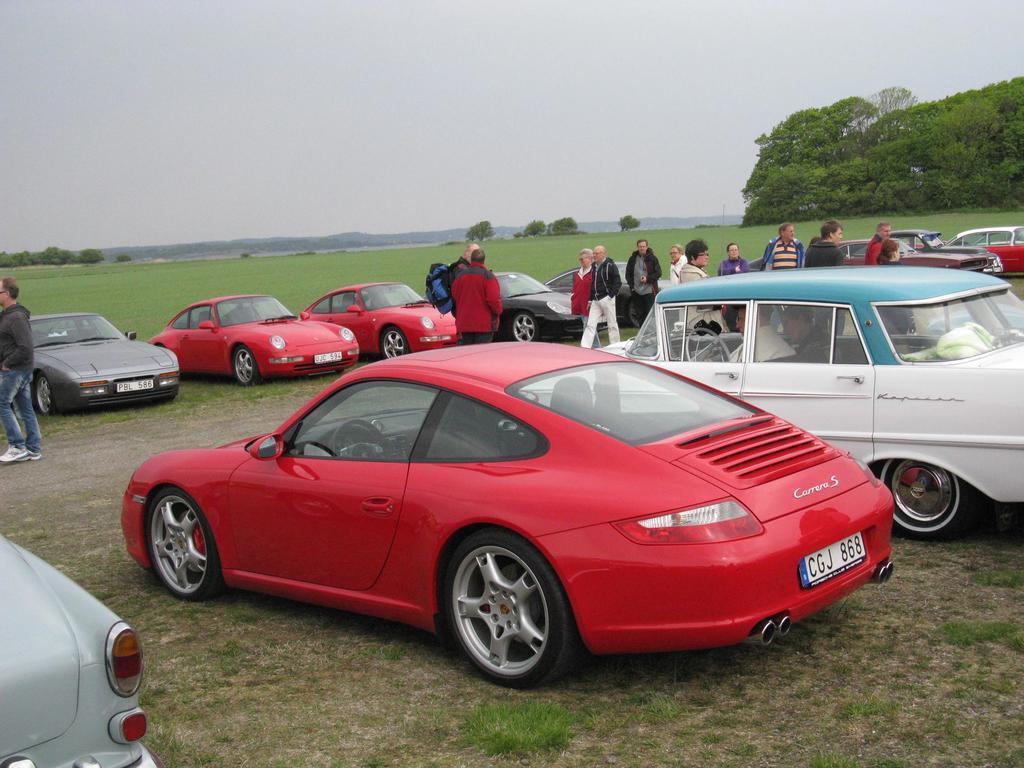Please provide a concise description of this image. In this image we can see many cars. There are many people in the image. There are many hills in the image. There is a grassy land in the image. There is the sky in the image. 